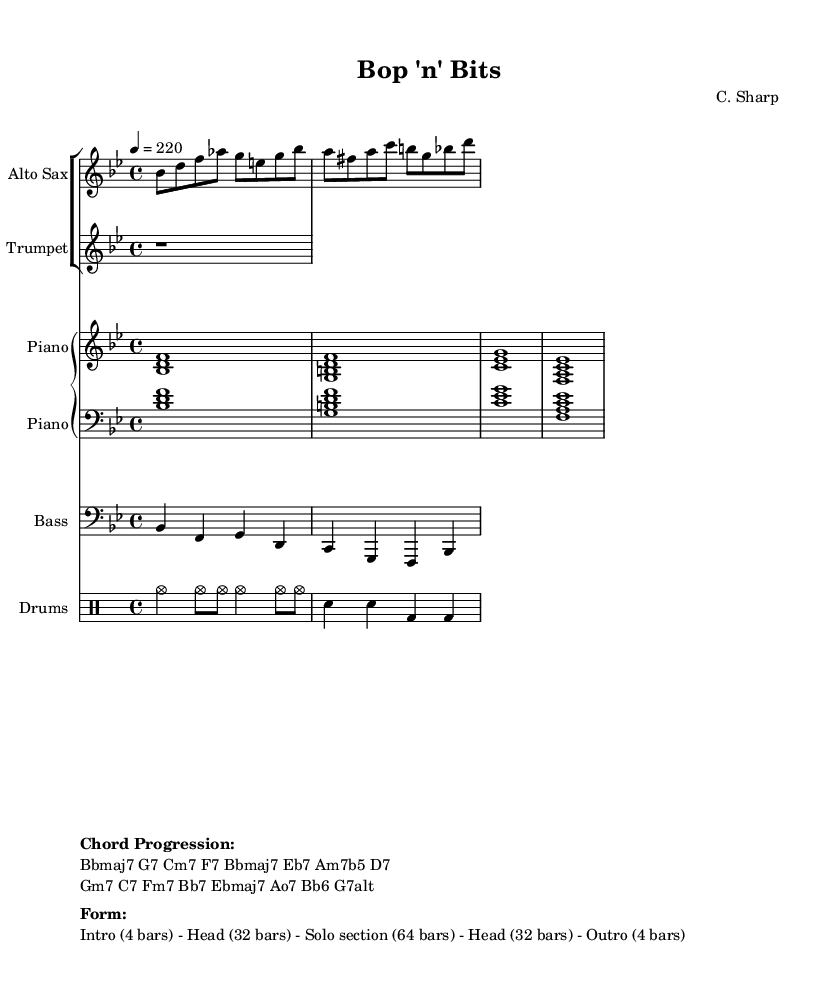What is the key signature of this music? The key signature is indicated by the `\key bes \major` command in the LilyPond code, which translates to B-flat major. This key signature has two flats (B-flat and E-flat).
Answer: B-flat major What is the time signature of this music? The time signature can be found in the LilyPond code as `\time 4/4`, which specifies four beats per measure, with a quarter note getting one beat.
Answer: 4/4 What is the tempo marking for this piece? The tempo is indicated by the command `\tempo 4 = 220`, meaning the quarter note should be played at a speed of 220 beats per minute.
Answer: 220 How many bars are in the head section? The head section is specified in the markup as consisting of 32 bars; this information is clearly stated under the "Form".
Answer: 32 What is the chord progression's first chord? The first chord of the provided progression is found at the beginning of the "Chord Progression" section in the markup; it is Bbmaj7.
Answer: Bbmaj7 What is the solo section's length in bars? The solo section is indicated in the markup as having 64 bars, and this is a direct interpretation of the written form.
Answer: 64 What type of improvisation style is represented in this piece? The piece exemplifies improvisation typical of bebop jazz, which is characterized by complex chord changes and fast tempos, as indicated by the style of the written melody and chords.
Answer: Bebop 